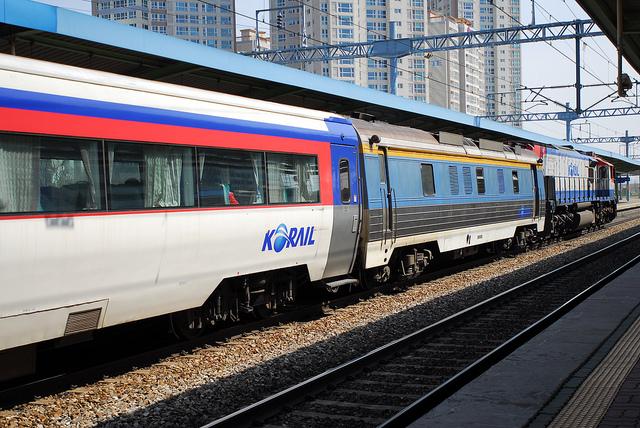Are all the cars the same color?
Short answer required. No. What quality photo is this?
Be succinct. Good. Is this train traveling on a street?
Be succinct. No. What is written on the train?
Be succinct. Korail. How many train cars?
Concise answer only. 3. 